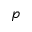<formula> <loc_0><loc_0><loc_500><loc_500>p</formula> 